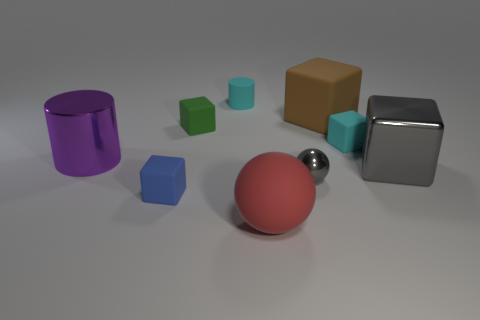Subtract all brown cubes. How many cubes are left? 4 Subtract all brown blocks. How many blocks are left? 4 Add 1 shiny cubes. How many objects exist? 10 Subtract 2 cubes. How many cubes are left? 3 Subtract all cylinders. How many objects are left? 7 Subtract all red cubes. Subtract all gray spheres. How many cubes are left? 5 Subtract all green cylinders. How many blue cubes are left? 1 Add 8 cyan matte cylinders. How many cyan matte cylinders are left? 9 Add 6 large gray things. How many large gray things exist? 7 Subtract 0 green cylinders. How many objects are left? 9 